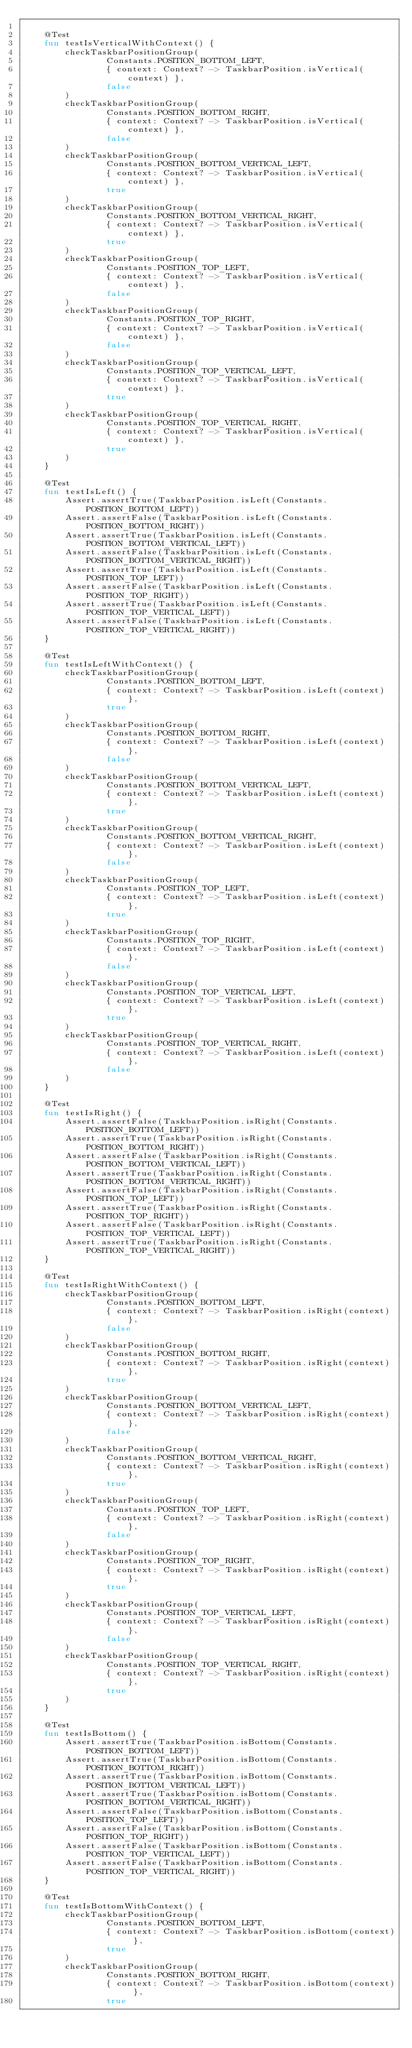<code> <loc_0><loc_0><loc_500><loc_500><_Kotlin_>
    @Test
    fun testIsVerticalWithContext() {
        checkTaskbarPositionGroup(
                Constants.POSITION_BOTTOM_LEFT,
                { context: Context? -> TaskbarPosition.isVertical(context) },
                false
        )
        checkTaskbarPositionGroup(
                Constants.POSITION_BOTTOM_RIGHT,
                { context: Context? -> TaskbarPosition.isVertical(context) },
                false
        )
        checkTaskbarPositionGroup(
                Constants.POSITION_BOTTOM_VERTICAL_LEFT,
                { context: Context? -> TaskbarPosition.isVertical(context) },
                true
        )
        checkTaskbarPositionGroup(
                Constants.POSITION_BOTTOM_VERTICAL_RIGHT,
                { context: Context? -> TaskbarPosition.isVertical(context) },
                true
        )
        checkTaskbarPositionGroup(
                Constants.POSITION_TOP_LEFT,
                { context: Context? -> TaskbarPosition.isVertical(context) },
                false
        )
        checkTaskbarPositionGroup(
                Constants.POSITION_TOP_RIGHT,
                { context: Context? -> TaskbarPosition.isVertical(context) },
                false
        )
        checkTaskbarPositionGroup(
                Constants.POSITION_TOP_VERTICAL_LEFT,
                { context: Context? -> TaskbarPosition.isVertical(context) },
                true
        )
        checkTaskbarPositionGroup(
                Constants.POSITION_TOP_VERTICAL_RIGHT,
                { context: Context? -> TaskbarPosition.isVertical(context) },
                true
        )
    }

    @Test
    fun testIsLeft() {
        Assert.assertTrue(TaskbarPosition.isLeft(Constants.POSITION_BOTTOM_LEFT))
        Assert.assertFalse(TaskbarPosition.isLeft(Constants.POSITION_BOTTOM_RIGHT))
        Assert.assertTrue(TaskbarPosition.isLeft(Constants.POSITION_BOTTOM_VERTICAL_LEFT))
        Assert.assertFalse(TaskbarPosition.isLeft(Constants.POSITION_BOTTOM_VERTICAL_RIGHT))
        Assert.assertTrue(TaskbarPosition.isLeft(Constants.POSITION_TOP_LEFT))
        Assert.assertFalse(TaskbarPosition.isLeft(Constants.POSITION_TOP_RIGHT))
        Assert.assertTrue(TaskbarPosition.isLeft(Constants.POSITION_TOP_VERTICAL_LEFT))
        Assert.assertFalse(TaskbarPosition.isLeft(Constants.POSITION_TOP_VERTICAL_RIGHT))
    }

    @Test
    fun testIsLeftWithContext() {
        checkTaskbarPositionGroup(
                Constants.POSITION_BOTTOM_LEFT,
                { context: Context? -> TaskbarPosition.isLeft(context) },
                true
        )
        checkTaskbarPositionGroup(
                Constants.POSITION_BOTTOM_RIGHT,
                { context: Context? -> TaskbarPosition.isLeft(context) },
                false
        )
        checkTaskbarPositionGroup(
                Constants.POSITION_BOTTOM_VERTICAL_LEFT,
                { context: Context? -> TaskbarPosition.isLeft(context) },
                true
        )
        checkTaskbarPositionGroup(
                Constants.POSITION_BOTTOM_VERTICAL_RIGHT,
                { context: Context? -> TaskbarPosition.isLeft(context) },
                false
        )
        checkTaskbarPositionGroup(
                Constants.POSITION_TOP_LEFT,
                { context: Context? -> TaskbarPosition.isLeft(context) },
                true
        )
        checkTaskbarPositionGroup(
                Constants.POSITION_TOP_RIGHT,
                { context: Context? -> TaskbarPosition.isLeft(context) },
                false
        )
        checkTaskbarPositionGroup(
                Constants.POSITION_TOP_VERTICAL_LEFT,
                { context: Context? -> TaskbarPosition.isLeft(context) },
                true
        )
        checkTaskbarPositionGroup(
                Constants.POSITION_TOP_VERTICAL_RIGHT,
                { context: Context? -> TaskbarPosition.isLeft(context) },
                false
        )
    }

    @Test
    fun testIsRight() {
        Assert.assertFalse(TaskbarPosition.isRight(Constants.POSITION_BOTTOM_LEFT))
        Assert.assertTrue(TaskbarPosition.isRight(Constants.POSITION_BOTTOM_RIGHT))
        Assert.assertFalse(TaskbarPosition.isRight(Constants.POSITION_BOTTOM_VERTICAL_LEFT))
        Assert.assertTrue(TaskbarPosition.isRight(Constants.POSITION_BOTTOM_VERTICAL_RIGHT))
        Assert.assertFalse(TaskbarPosition.isRight(Constants.POSITION_TOP_LEFT))
        Assert.assertTrue(TaskbarPosition.isRight(Constants.POSITION_TOP_RIGHT))
        Assert.assertFalse(TaskbarPosition.isRight(Constants.POSITION_TOP_VERTICAL_LEFT))
        Assert.assertTrue(TaskbarPosition.isRight(Constants.POSITION_TOP_VERTICAL_RIGHT))
    }

    @Test
    fun testIsRightWithContext() {
        checkTaskbarPositionGroup(
                Constants.POSITION_BOTTOM_LEFT,
                { context: Context? -> TaskbarPosition.isRight(context) },
                false
        )
        checkTaskbarPositionGroup(
                Constants.POSITION_BOTTOM_RIGHT,
                { context: Context? -> TaskbarPosition.isRight(context) },
                true
        )
        checkTaskbarPositionGroup(
                Constants.POSITION_BOTTOM_VERTICAL_LEFT,
                { context: Context? -> TaskbarPosition.isRight(context) },
                false
        )
        checkTaskbarPositionGroup(
                Constants.POSITION_BOTTOM_VERTICAL_RIGHT,
                { context: Context? -> TaskbarPosition.isRight(context) },
                true
        )
        checkTaskbarPositionGroup(
                Constants.POSITION_TOP_LEFT,
                { context: Context? -> TaskbarPosition.isRight(context) },
                false
        )
        checkTaskbarPositionGroup(
                Constants.POSITION_TOP_RIGHT,
                { context: Context? -> TaskbarPosition.isRight(context) },
                true
        )
        checkTaskbarPositionGroup(
                Constants.POSITION_TOP_VERTICAL_LEFT,
                { context: Context? -> TaskbarPosition.isRight(context) },
                false
        )
        checkTaskbarPositionGroup(
                Constants.POSITION_TOP_VERTICAL_RIGHT,
                { context: Context? -> TaskbarPosition.isRight(context) },
                true
        )
    }

    @Test
    fun testIsBottom() {
        Assert.assertTrue(TaskbarPosition.isBottom(Constants.POSITION_BOTTOM_LEFT))
        Assert.assertTrue(TaskbarPosition.isBottom(Constants.POSITION_BOTTOM_RIGHT))
        Assert.assertTrue(TaskbarPosition.isBottom(Constants.POSITION_BOTTOM_VERTICAL_LEFT))
        Assert.assertTrue(TaskbarPosition.isBottom(Constants.POSITION_BOTTOM_VERTICAL_RIGHT))
        Assert.assertFalse(TaskbarPosition.isBottom(Constants.POSITION_TOP_LEFT))
        Assert.assertFalse(TaskbarPosition.isBottom(Constants.POSITION_TOP_RIGHT))
        Assert.assertFalse(TaskbarPosition.isBottom(Constants.POSITION_TOP_VERTICAL_LEFT))
        Assert.assertFalse(TaskbarPosition.isBottom(Constants.POSITION_TOP_VERTICAL_RIGHT))
    }

    @Test
    fun testIsBottomWithContext() {
        checkTaskbarPositionGroup(
                Constants.POSITION_BOTTOM_LEFT,
                { context: Context? -> TaskbarPosition.isBottom(context) },
                true
        )
        checkTaskbarPositionGroup(
                Constants.POSITION_BOTTOM_RIGHT,
                { context: Context? -> TaskbarPosition.isBottom(context) },
                true</code> 